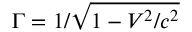Convert formula to latex. <formula><loc_0><loc_0><loc_500><loc_500>\Gamma = 1 / \sqrt { 1 - V ^ { 2 } / c ^ { 2 } }</formula> 